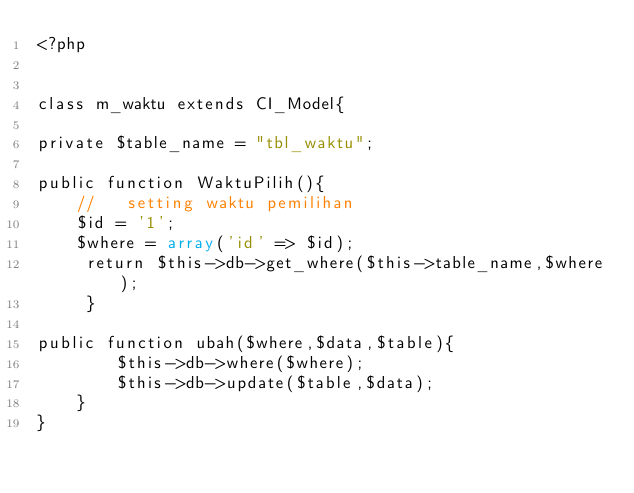<code> <loc_0><loc_0><loc_500><loc_500><_PHP_><?php


class m_waktu extends CI_Model{

private $table_name = "tbl_waktu";

public function WaktuPilih(){
    //   setting waktu pemilihan
    $id = '1';
    $where = array('id' => $id);
     return $this->db->get_where($this->table_name,$where);
     }
       
public function ubah($where,$data,$table){
        $this->db->where($where);
        $this->db->update($table,$data);
    }
}
</code> 